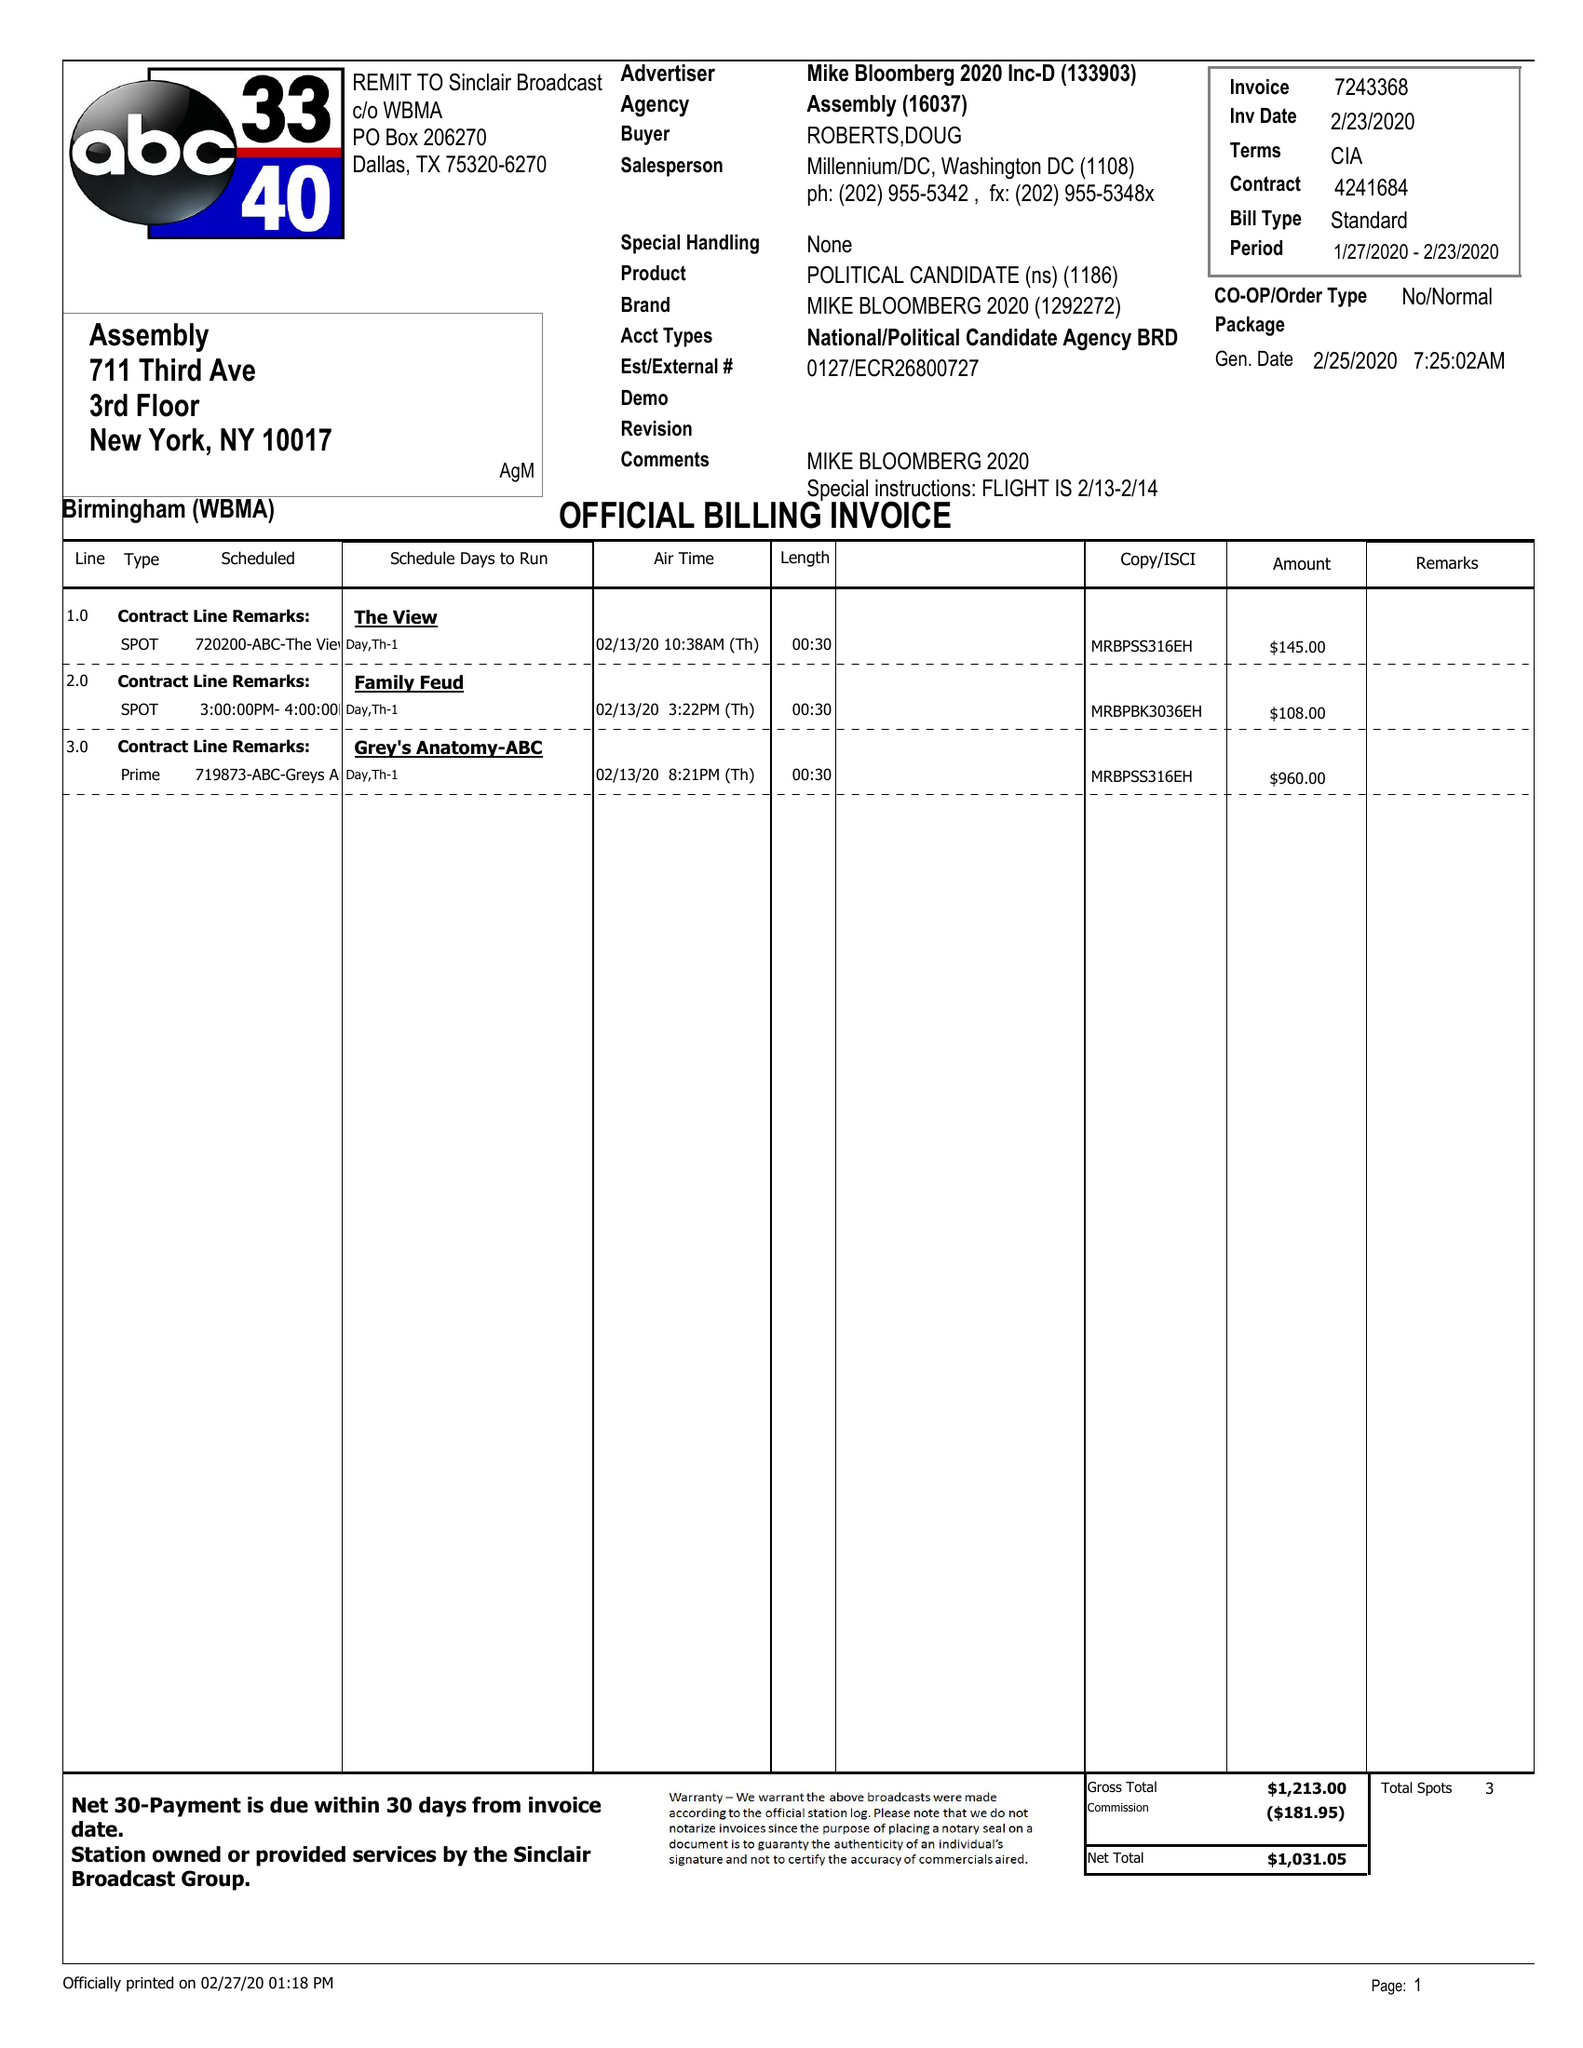What is the value for the flight_from?
Answer the question using a single word or phrase. 01/27/20 